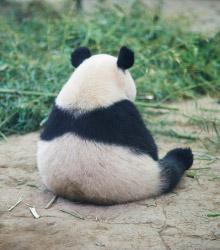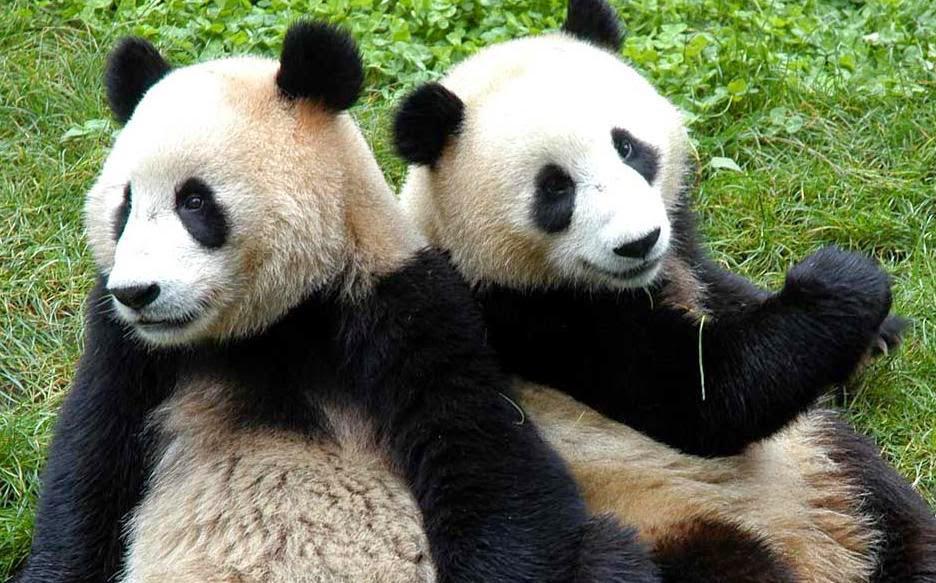The first image is the image on the left, the second image is the image on the right. Examine the images to the left and right. Is the description "There is a total of three pandas." accurate? Answer yes or no. Yes. The first image is the image on the left, the second image is the image on the right. Evaluate the accuracy of this statement regarding the images: "Two pandas are playing together in each of the images.". Is it true? Answer yes or no. No. 